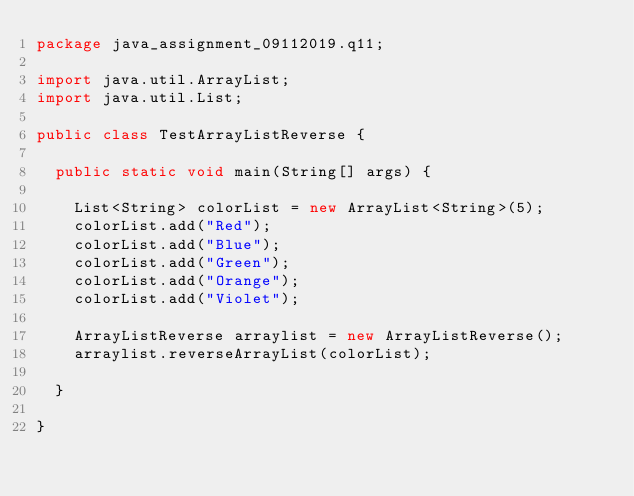Convert code to text. <code><loc_0><loc_0><loc_500><loc_500><_Java_>package java_assignment_09112019.q11;

import java.util.ArrayList;
import java.util.List;

public class TestArrayListReverse {

	public static void main(String[] args) {
		
		List<String> colorList = new ArrayList<String>(5);
		colorList.add("Red");
		colorList.add("Blue");
		colorList.add("Green");
		colorList.add("Orange");
		colorList.add("Violet");
		
		ArrayListReverse arraylist = new ArrayListReverse();
		arraylist.reverseArrayList(colorList);

	}

}
</code> 